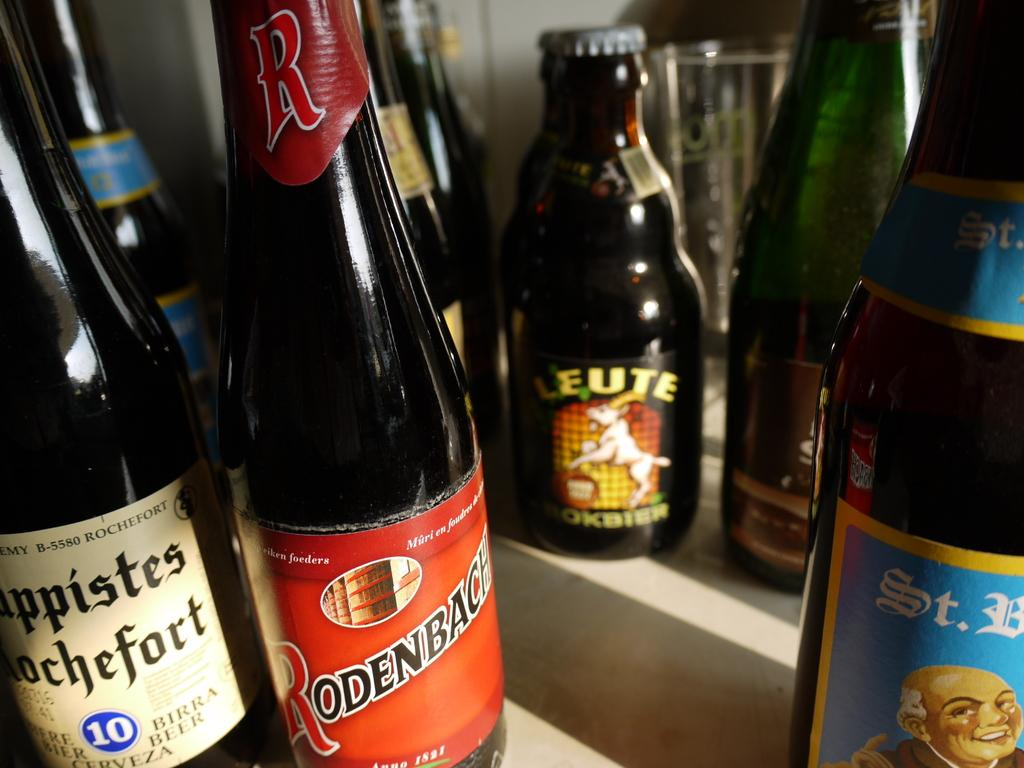<image>
Describe the image concisely. Many bottles on a table including one that says "Rodenbach". 